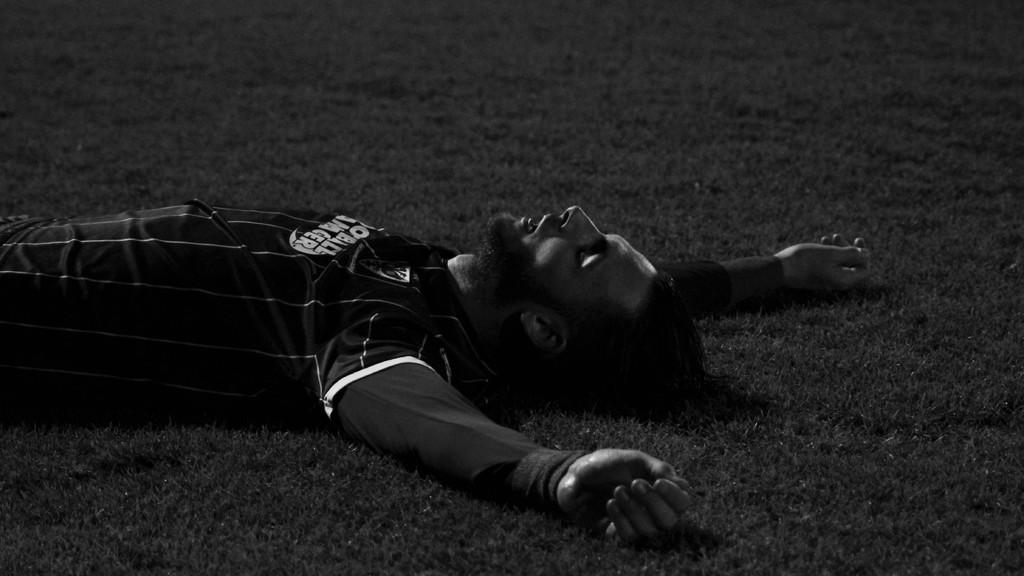What is the color scheme of the image? The image is black and white. Can you describe the person in the image? There is a person in the image, and they are wearing a black dress. What is the person's position in the image? The person is laying on the ground. What type of achievement is the person celebrating in the image? There is no indication of an achievement or celebration in the image, as the person is laying on the ground. What is the reason for the protest in the image? There is no protest present in the image; it only features a person laying on the ground. 